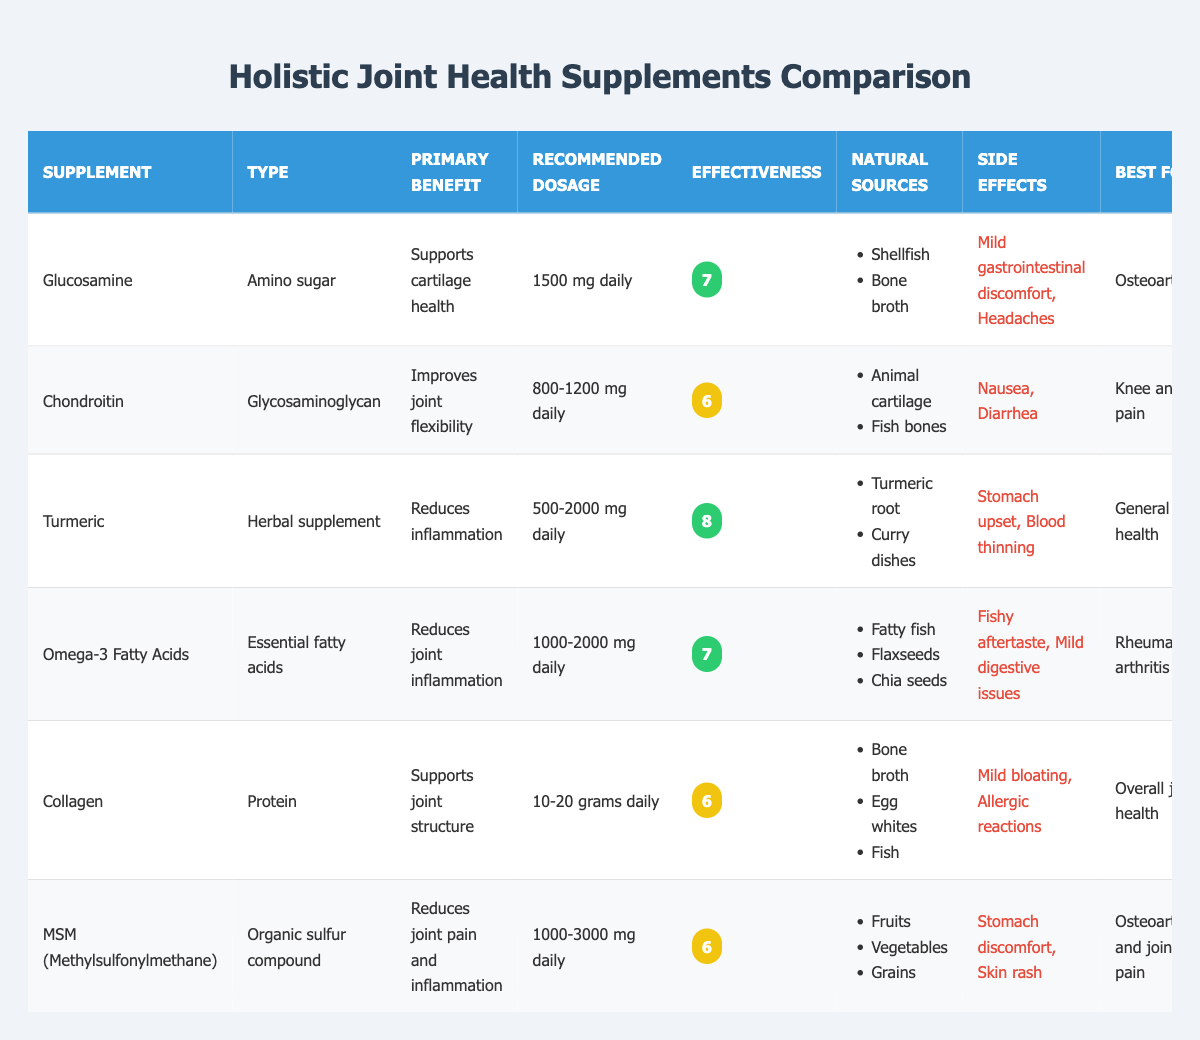What is the recommended daily dosage for Turmeric? The table lists the recommended dosage for Turmeric as "500-2000 mg daily." This information is directly provided in the "Recommended Dosage" column for the Turmeric row.
Answer: 500-2000 mg daily Which supplement has the highest effectiveness rating? By scanning the "Effectiveness" column, Turmeric has the highest rating of 8. Thus, Turmeric is the supplement noted for the greatest effectiveness.
Answer: Turmeric Does Glucosamine have any side effects? The table states that Glucosamine has side effects listed as "Mild gastrointestinal discomfort" and "Headaches." This confirms that Glucosamine does indeed have side effects.
Answer: Yes What are the natural sources of Omega-3 Fatty Acids? The "Natural Sources" column for Omega-3 Fatty Acids lists "Fatty fish," "Flaxseeds," and "Chia seeds." These items are derived from the information provided in the table.
Answer: Fatty fish, Flaxseeds, Chia seeds Which supplements are classified as having high holistic compatibility? By inspecting the "Holistic Compatibility" column, Glucosamine, Turmeric, Omega-3 Fatty Acids, Collagen have "High" compatibility while Turmeric is noted as "Very high."
Answer: Glucosamine, Turmeric, Omega-3 Fatty Acids, Collagen What is the average effectiveness rating for the supplements? The effectiveness ratings are 7, 6, 8, 7, 6, and 6. Adding these together (7 + 6 + 8 + 7 + 6 + 6) results in 40. Dividing by the number of supplements (6) gives an average of 40/6, which is approximately 6.67.
Answer: 6.67 Is Chondroitin suitable for individuals with knee and hip pain? The table indicates that Chondroitin is best for "Knee and hip pain," confirming its suitability for individuals experiencing pain in these areas.
Answer: Yes How many supplements are specifically recommended for osteoarthritis? By examining the "Best For" column, Glucosamine and MSM are both noted as being best for "Osteoarthritis." Counting these entries gives a total of two supplements.
Answer: 2 What side effects are associated with Collagen? The table documents the side effects of Collagen as "Mild bloating" and "Allergic reactions." This information is clearly stated in the corresponding row under "Side Effects."
Answer: Mild bloating, Allergic reactions 